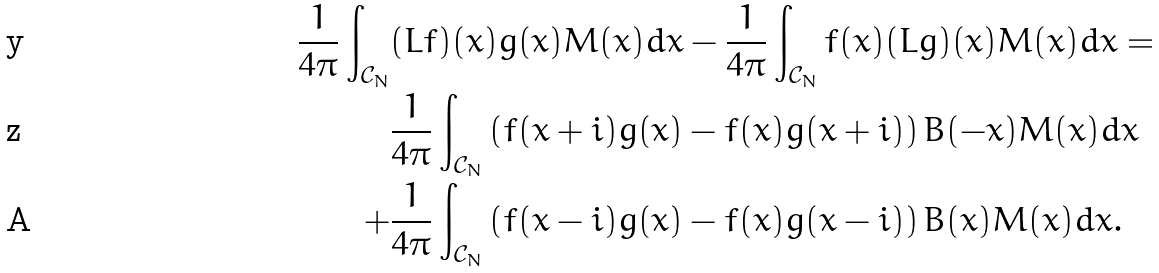<formula> <loc_0><loc_0><loc_500><loc_500>\frac { 1 } { 4 \pi } \int _ { \mathcal { C } _ { N } } & ( L f ) ( x ) g ( x ) M ( x ) d x - \frac { 1 } { 4 \pi } \int _ { \mathcal { C } _ { N } } f ( x ) ( L g ) ( x ) M ( x ) d x = \\ & \frac { 1 } { 4 \pi } \int _ { \mathcal { C } _ { N } } \left ( f ( x + i ) g ( x ) - f ( x ) g ( x + i ) \right ) B ( - x ) M ( x ) d x \\ + & \frac { 1 } { 4 \pi } \int _ { \mathcal { C } _ { N } } \left ( f ( x - i ) g ( x ) - f ( x ) g ( x - i ) \right ) B ( x ) M ( x ) d x .</formula> 